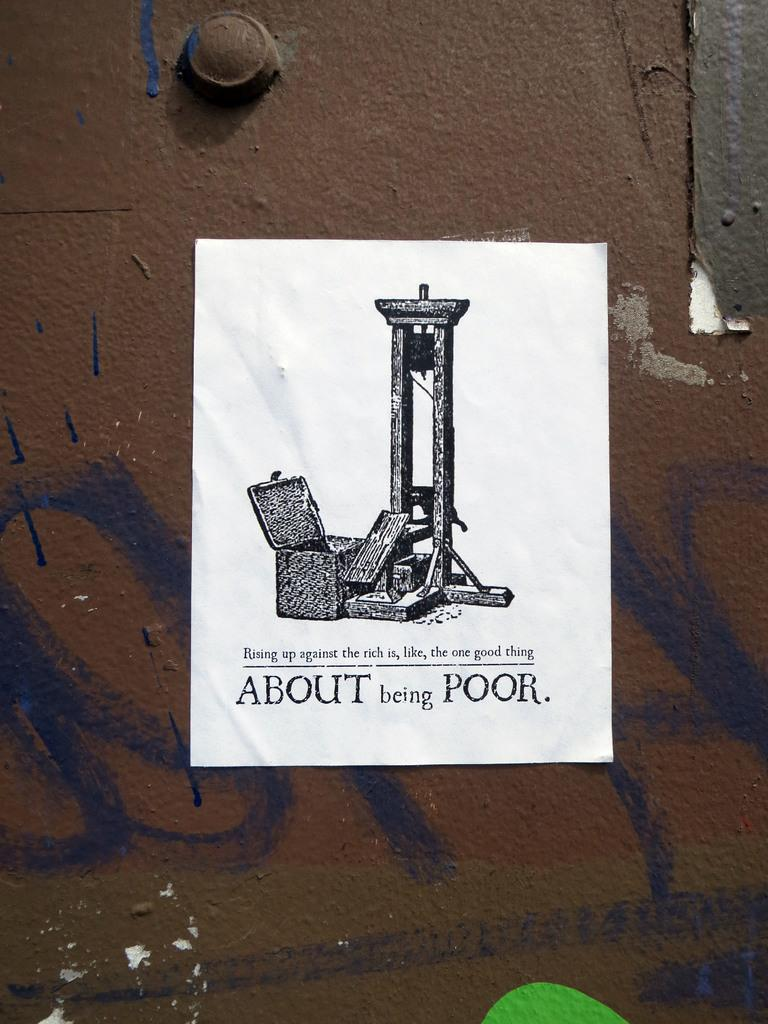<image>
Present a compact description of the photo's key features. A poster "about being poor" is taped over some grafitti on a wall 